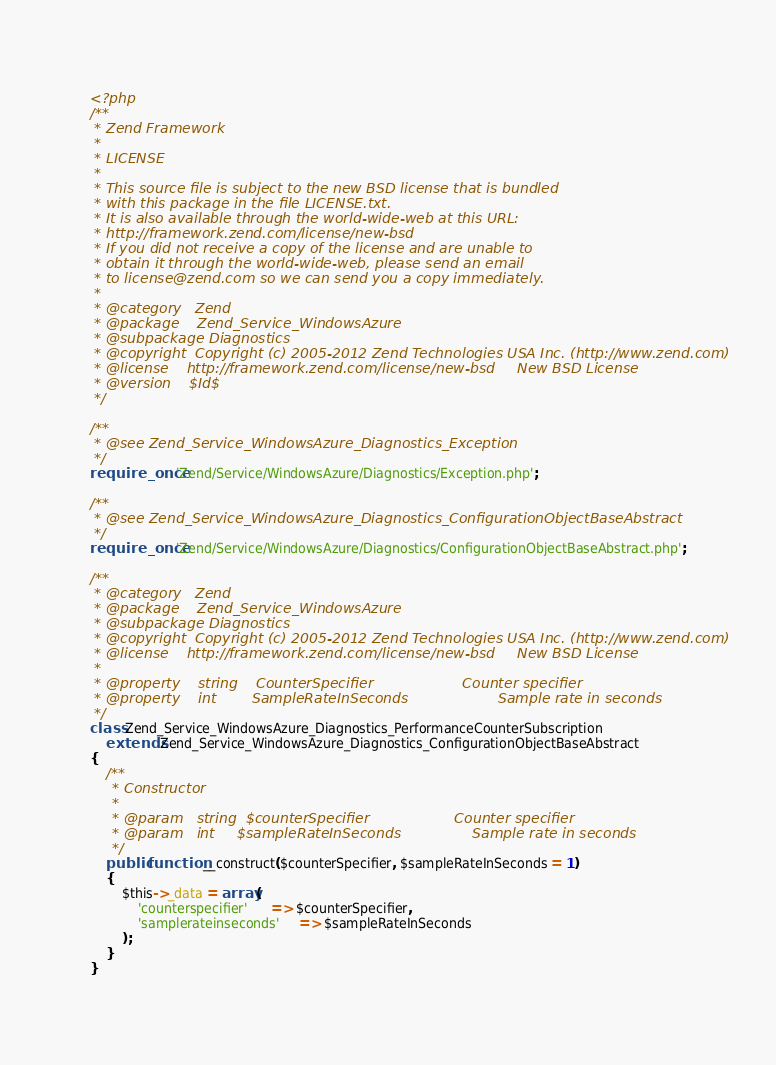Convert code to text. <code><loc_0><loc_0><loc_500><loc_500><_PHP_><?php
/**
 * Zend Framework
 *
 * LICENSE
 *
 * This source file is subject to the new BSD license that is bundled
 * with this package in the file LICENSE.txt.
 * It is also available through the world-wide-web at this URL:
 * http://framework.zend.com/license/new-bsd
 * If you did not receive a copy of the license and are unable to
 * obtain it through the world-wide-web, please send an email
 * to license@zend.com so we can send you a copy immediately.
 *
 * @category   Zend
 * @package    Zend_Service_WindowsAzure
 * @subpackage Diagnostics
 * @copyright  Copyright (c) 2005-2012 Zend Technologies USA Inc. (http://www.zend.com)
 * @license    http://framework.zend.com/license/new-bsd     New BSD License
 * @version    $Id$
 */

/**
 * @see Zend_Service_WindowsAzure_Diagnostics_Exception
 */
require_once 'Zend/Service/WindowsAzure/Diagnostics/Exception.php';

/**
 * @see Zend_Service_WindowsAzure_Diagnostics_ConfigurationObjectBaseAbstract
 */
require_once 'Zend/Service/WindowsAzure/Diagnostics/ConfigurationObjectBaseAbstract.php';

/**
 * @category   Zend
 * @package    Zend_Service_WindowsAzure
 * @subpackage Diagnostics
 * @copyright  Copyright (c) 2005-2012 Zend Technologies USA Inc. (http://www.zend.com)
 * @license    http://framework.zend.com/license/new-bsd     New BSD License
 *
 * @property    string    CounterSpecifier                    Counter specifier
 * @property    int        SampleRateInSeconds                    Sample rate in seconds
 */
class Zend_Service_WindowsAzure_Diagnostics_PerformanceCounterSubscription
    extends Zend_Service_WindowsAzure_Diagnostics_ConfigurationObjectBaseAbstract
{
    /**
     * Constructor
     *
 	 * @param	string	$counterSpecifier					Counter specifier
 	 * @param	int		$sampleRateInSeconds				Sample rate in seconds
	 */
    public function __construct($counterSpecifier, $sampleRateInSeconds = 1)
    {	
        $this->_data = array(
            'counterspecifier'      => $counterSpecifier,
            'samplerateinseconds'     => $sampleRateInSeconds
        );
    }
}
</code> 